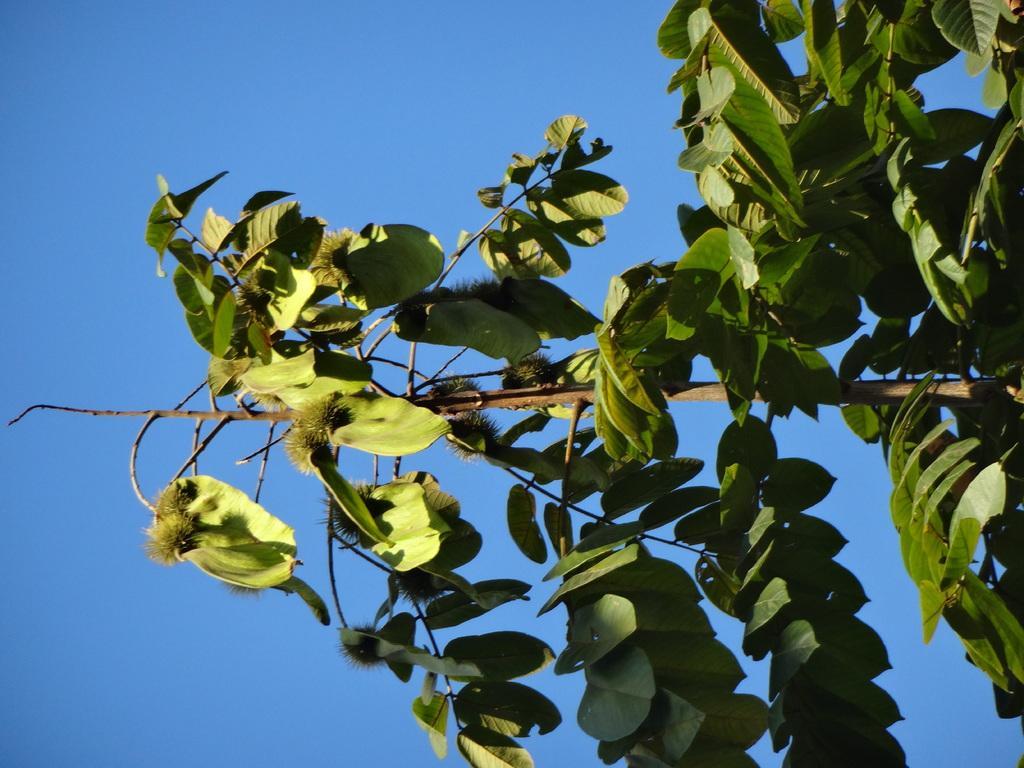Can you describe this image briefly? In this image we can see a tree. On the backside we can see the sky. 